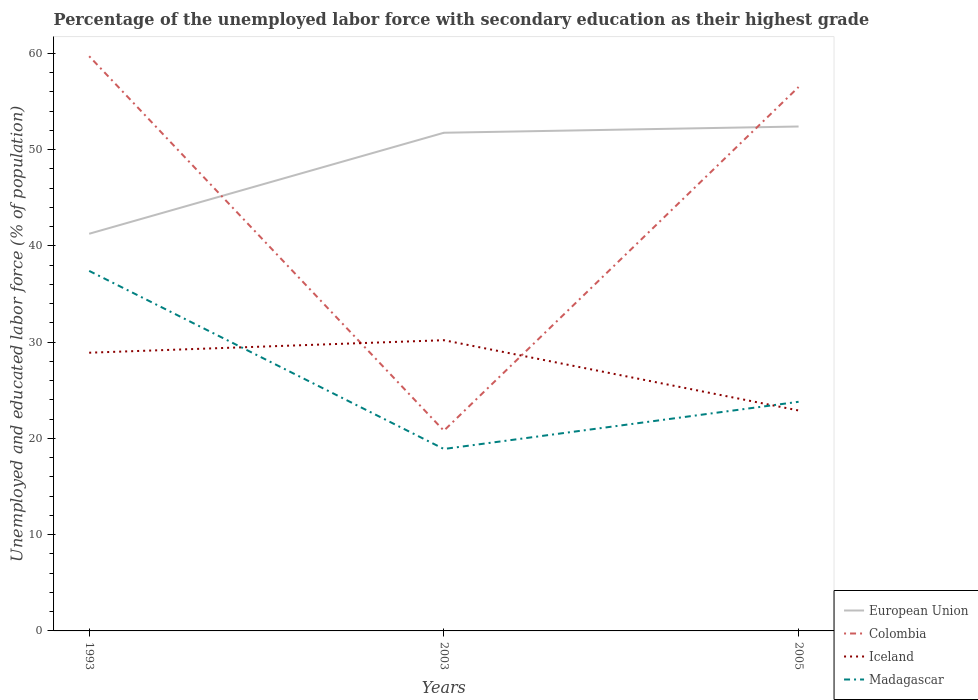Does the line corresponding to European Union intersect with the line corresponding to Iceland?
Keep it short and to the point. No. Across all years, what is the maximum percentage of the unemployed labor force with secondary education in Iceland?
Your answer should be compact. 22.9. What is the total percentage of the unemployed labor force with secondary education in Madagascar in the graph?
Keep it short and to the point. 18.5. What is the difference between the highest and the second highest percentage of the unemployed labor force with secondary education in European Union?
Give a very brief answer. 11.14. What is the difference between the highest and the lowest percentage of the unemployed labor force with secondary education in Madagascar?
Provide a succinct answer. 1. Is the percentage of the unemployed labor force with secondary education in Madagascar strictly greater than the percentage of the unemployed labor force with secondary education in European Union over the years?
Ensure brevity in your answer.  Yes. Are the values on the major ticks of Y-axis written in scientific E-notation?
Your answer should be very brief. No. Does the graph contain grids?
Give a very brief answer. No. What is the title of the graph?
Ensure brevity in your answer.  Percentage of the unemployed labor force with secondary education as their highest grade. Does "China" appear as one of the legend labels in the graph?
Your answer should be compact. No. What is the label or title of the Y-axis?
Offer a very short reply. Unemployed and educated labor force (% of population). What is the Unemployed and educated labor force (% of population) in European Union in 1993?
Provide a succinct answer. 41.26. What is the Unemployed and educated labor force (% of population) of Colombia in 1993?
Ensure brevity in your answer.  59.7. What is the Unemployed and educated labor force (% of population) in Iceland in 1993?
Your answer should be very brief. 28.9. What is the Unemployed and educated labor force (% of population) in Madagascar in 1993?
Your answer should be very brief. 37.4. What is the Unemployed and educated labor force (% of population) in European Union in 2003?
Offer a very short reply. 51.75. What is the Unemployed and educated labor force (% of population) of Colombia in 2003?
Your answer should be compact. 20.8. What is the Unemployed and educated labor force (% of population) in Iceland in 2003?
Ensure brevity in your answer.  30.2. What is the Unemployed and educated labor force (% of population) in Madagascar in 2003?
Your response must be concise. 18.9. What is the Unemployed and educated labor force (% of population) of European Union in 2005?
Your response must be concise. 52.4. What is the Unemployed and educated labor force (% of population) of Colombia in 2005?
Offer a terse response. 56.5. What is the Unemployed and educated labor force (% of population) in Iceland in 2005?
Make the answer very short. 22.9. What is the Unemployed and educated labor force (% of population) in Madagascar in 2005?
Your answer should be compact. 23.8. Across all years, what is the maximum Unemployed and educated labor force (% of population) in European Union?
Make the answer very short. 52.4. Across all years, what is the maximum Unemployed and educated labor force (% of population) of Colombia?
Keep it short and to the point. 59.7. Across all years, what is the maximum Unemployed and educated labor force (% of population) in Iceland?
Make the answer very short. 30.2. Across all years, what is the maximum Unemployed and educated labor force (% of population) of Madagascar?
Your answer should be compact. 37.4. Across all years, what is the minimum Unemployed and educated labor force (% of population) of European Union?
Provide a succinct answer. 41.26. Across all years, what is the minimum Unemployed and educated labor force (% of population) of Colombia?
Your answer should be compact. 20.8. Across all years, what is the minimum Unemployed and educated labor force (% of population) in Iceland?
Offer a very short reply. 22.9. Across all years, what is the minimum Unemployed and educated labor force (% of population) in Madagascar?
Ensure brevity in your answer.  18.9. What is the total Unemployed and educated labor force (% of population) of European Union in the graph?
Ensure brevity in your answer.  145.4. What is the total Unemployed and educated labor force (% of population) of Colombia in the graph?
Your answer should be compact. 137. What is the total Unemployed and educated labor force (% of population) in Iceland in the graph?
Make the answer very short. 82. What is the total Unemployed and educated labor force (% of population) of Madagascar in the graph?
Give a very brief answer. 80.1. What is the difference between the Unemployed and educated labor force (% of population) in European Union in 1993 and that in 2003?
Your response must be concise. -10.49. What is the difference between the Unemployed and educated labor force (% of population) of Colombia in 1993 and that in 2003?
Offer a terse response. 38.9. What is the difference between the Unemployed and educated labor force (% of population) in Iceland in 1993 and that in 2003?
Make the answer very short. -1.3. What is the difference between the Unemployed and educated labor force (% of population) of Madagascar in 1993 and that in 2003?
Give a very brief answer. 18.5. What is the difference between the Unemployed and educated labor force (% of population) in European Union in 1993 and that in 2005?
Offer a very short reply. -11.14. What is the difference between the Unemployed and educated labor force (% of population) of Colombia in 1993 and that in 2005?
Give a very brief answer. 3.2. What is the difference between the Unemployed and educated labor force (% of population) in Iceland in 1993 and that in 2005?
Your answer should be very brief. 6. What is the difference between the Unemployed and educated labor force (% of population) of Madagascar in 1993 and that in 2005?
Ensure brevity in your answer.  13.6. What is the difference between the Unemployed and educated labor force (% of population) in European Union in 2003 and that in 2005?
Provide a short and direct response. -0.65. What is the difference between the Unemployed and educated labor force (% of population) of Colombia in 2003 and that in 2005?
Your answer should be compact. -35.7. What is the difference between the Unemployed and educated labor force (% of population) of Madagascar in 2003 and that in 2005?
Provide a short and direct response. -4.9. What is the difference between the Unemployed and educated labor force (% of population) of European Union in 1993 and the Unemployed and educated labor force (% of population) of Colombia in 2003?
Give a very brief answer. 20.46. What is the difference between the Unemployed and educated labor force (% of population) in European Union in 1993 and the Unemployed and educated labor force (% of population) in Iceland in 2003?
Make the answer very short. 11.06. What is the difference between the Unemployed and educated labor force (% of population) in European Union in 1993 and the Unemployed and educated labor force (% of population) in Madagascar in 2003?
Make the answer very short. 22.36. What is the difference between the Unemployed and educated labor force (% of population) in Colombia in 1993 and the Unemployed and educated labor force (% of population) in Iceland in 2003?
Offer a terse response. 29.5. What is the difference between the Unemployed and educated labor force (% of population) of Colombia in 1993 and the Unemployed and educated labor force (% of population) of Madagascar in 2003?
Your answer should be compact. 40.8. What is the difference between the Unemployed and educated labor force (% of population) of European Union in 1993 and the Unemployed and educated labor force (% of population) of Colombia in 2005?
Your answer should be very brief. -15.24. What is the difference between the Unemployed and educated labor force (% of population) of European Union in 1993 and the Unemployed and educated labor force (% of population) of Iceland in 2005?
Give a very brief answer. 18.36. What is the difference between the Unemployed and educated labor force (% of population) of European Union in 1993 and the Unemployed and educated labor force (% of population) of Madagascar in 2005?
Offer a very short reply. 17.46. What is the difference between the Unemployed and educated labor force (% of population) in Colombia in 1993 and the Unemployed and educated labor force (% of population) in Iceland in 2005?
Your answer should be very brief. 36.8. What is the difference between the Unemployed and educated labor force (% of population) in Colombia in 1993 and the Unemployed and educated labor force (% of population) in Madagascar in 2005?
Offer a very short reply. 35.9. What is the difference between the Unemployed and educated labor force (% of population) of European Union in 2003 and the Unemployed and educated labor force (% of population) of Colombia in 2005?
Keep it short and to the point. -4.75. What is the difference between the Unemployed and educated labor force (% of population) of European Union in 2003 and the Unemployed and educated labor force (% of population) of Iceland in 2005?
Keep it short and to the point. 28.85. What is the difference between the Unemployed and educated labor force (% of population) in European Union in 2003 and the Unemployed and educated labor force (% of population) in Madagascar in 2005?
Provide a short and direct response. 27.95. What is the difference between the Unemployed and educated labor force (% of population) in Iceland in 2003 and the Unemployed and educated labor force (% of population) in Madagascar in 2005?
Ensure brevity in your answer.  6.4. What is the average Unemployed and educated labor force (% of population) in European Union per year?
Your answer should be compact. 48.47. What is the average Unemployed and educated labor force (% of population) of Colombia per year?
Ensure brevity in your answer.  45.67. What is the average Unemployed and educated labor force (% of population) in Iceland per year?
Your answer should be very brief. 27.33. What is the average Unemployed and educated labor force (% of population) in Madagascar per year?
Keep it short and to the point. 26.7. In the year 1993, what is the difference between the Unemployed and educated labor force (% of population) in European Union and Unemployed and educated labor force (% of population) in Colombia?
Make the answer very short. -18.44. In the year 1993, what is the difference between the Unemployed and educated labor force (% of population) in European Union and Unemployed and educated labor force (% of population) in Iceland?
Your response must be concise. 12.36. In the year 1993, what is the difference between the Unemployed and educated labor force (% of population) of European Union and Unemployed and educated labor force (% of population) of Madagascar?
Offer a terse response. 3.86. In the year 1993, what is the difference between the Unemployed and educated labor force (% of population) of Colombia and Unemployed and educated labor force (% of population) of Iceland?
Provide a succinct answer. 30.8. In the year 1993, what is the difference between the Unemployed and educated labor force (% of population) in Colombia and Unemployed and educated labor force (% of population) in Madagascar?
Provide a short and direct response. 22.3. In the year 1993, what is the difference between the Unemployed and educated labor force (% of population) in Iceland and Unemployed and educated labor force (% of population) in Madagascar?
Keep it short and to the point. -8.5. In the year 2003, what is the difference between the Unemployed and educated labor force (% of population) in European Union and Unemployed and educated labor force (% of population) in Colombia?
Offer a very short reply. 30.95. In the year 2003, what is the difference between the Unemployed and educated labor force (% of population) in European Union and Unemployed and educated labor force (% of population) in Iceland?
Offer a terse response. 21.55. In the year 2003, what is the difference between the Unemployed and educated labor force (% of population) in European Union and Unemployed and educated labor force (% of population) in Madagascar?
Ensure brevity in your answer.  32.85. In the year 2003, what is the difference between the Unemployed and educated labor force (% of population) in Colombia and Unemployed and educated labor force (% of population) in Iceland?
Offer a very short reply. -9.4. In the year 2003, what is the difference between the Unemployed and educated labor force (% of population) in Iceland and Unemployed and educated labor force (% of population) in Madagascar?
Keep it short and to the point. 11.3. In the year 2005, what is the difference between the Unemployed and educated labor force (% of population) in European Union and Unemployed and educated labor force (% of population) in Colombia?
Ensure brevity in your answer.  -4.1. In the year 2005, what is the difference between the Unemployed and educated labor force (% of population) of European Union and Unemployed and educated labor force (% of population) of Iceland?
Ensure brevity in your answer.  29.5. In the year 2005, what is the difference between the Unemployed and educated labor force (% of population) of European Union and Unemployed and educated labor force (% of population) of Madagascar?
Offer a very short reply. 28.6. In the year 2005, what is the difference between the Unemployed and educated labor force (% of population) in Colombia and Unemployed and educated labor force (% of population) in Iceland?
Offer a very short reply. 33.6. In the year 2005, what is the difference between the Unemployed and educated labor force (% of population) of Colombia and Unemployed and educated labor force (% of population) of Madagascar?
Ensure brevity in your answer.  32.7. What is the ratio of the Unemployed and educated labor force (% of population) in European Union in 1993 to that in 2003?
Your response must be concise. 0.8. What is the ratio of the Unemployed and educated labor force (% of population) in Colombia in 1993 to that in 2003?
Provide a short and direct response. 2.87. What is the ratio of the Unemployed and educated labor force (% of population) of Iceland in 1993 to that in 2003?
Keep it short and to the point. 0.96. What is the ratio of the Unemployed and educated labor force (% of population) in Madagascar in 1993 to that in 2003?
Keep it short and to the point. 1.98. What is the ratio of the Unemployed and educated labor force (% of population) in European Union in 1993 to that in 2005?
Your answer should be very brief. 0.79. What is the ratio of the Unemployed and educated labor force (% of population) of Colombia in 1993 to that in 2005?
Keep it short and to the point. 1.06. What is the ratio of the Unemployed and educated labor force (% of population) in Iceland in 1993 to that in 2005?
Offer a very short reply. 1.26. What is the ratio of the Unemployed and educated labor force (% of population) in Madagascar in 1993 to that in 2005?
Ensure brevity in your answer.  1.57. What is the ratio of the Unemployed and educated labor force (% of population) of European Union in 2003 to that in 2005?
Your answer should be compact. 0.99. What is the ratio of the Unemployed and educated labor force (% of population) of Colombia in 2003 to that in 2005?
Offer a terse response. 0.37. What is the ratio of the Unemployed and educated labor force (% of population) in Iceland in 2003 to that in 2005?
Your response must be concise. 1.32. What is the ratio of the Unemployed and educated labor force (% of population) in Madagascar in 2003 to that in 2005?
Ensure brevity in your answer.  0.79. What is the difference between the highest and the second highest Unemployed and educated labor force (% of population) in European Union?
Give a very brief answer. 0.65. What is the difference between the highest and the second highest Unemployed and educated labor force (% of population) in Iceland?
Ensure brevity in your answer.  1.3. What is the difference between the highest and the second highest Unemployed and educated labor force (% of population) of Madagascar?
Keep it short and to the point. 13.6. What is the difference between the highest and the lowest Unemployed and educated labor force (% of population) of European Union?
Keep it short and to the point. 11.14. What is the difference between the highest and the lowest Unemployed and educated labor force (% of population) in Colombia?
Provide a short and direct response. 38.9. What is the difference between the highest and the lowest Unemployed and educated labor force (% of population) of Madagascar?
Keep it short and to the point. 18.5. 